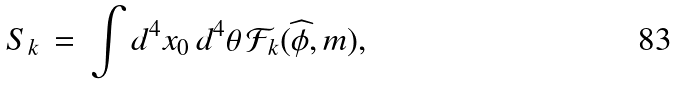<formula> <loc_0><loc_0><loc_500><loc_500>S _ { k } \, = \, \int d ^ { 4 } x _ { 0 } \, d ^ { 4 } \theta \, \mathcal { F } _ { k } ( { \widehat { \phi } } , m ) ,</formula> 